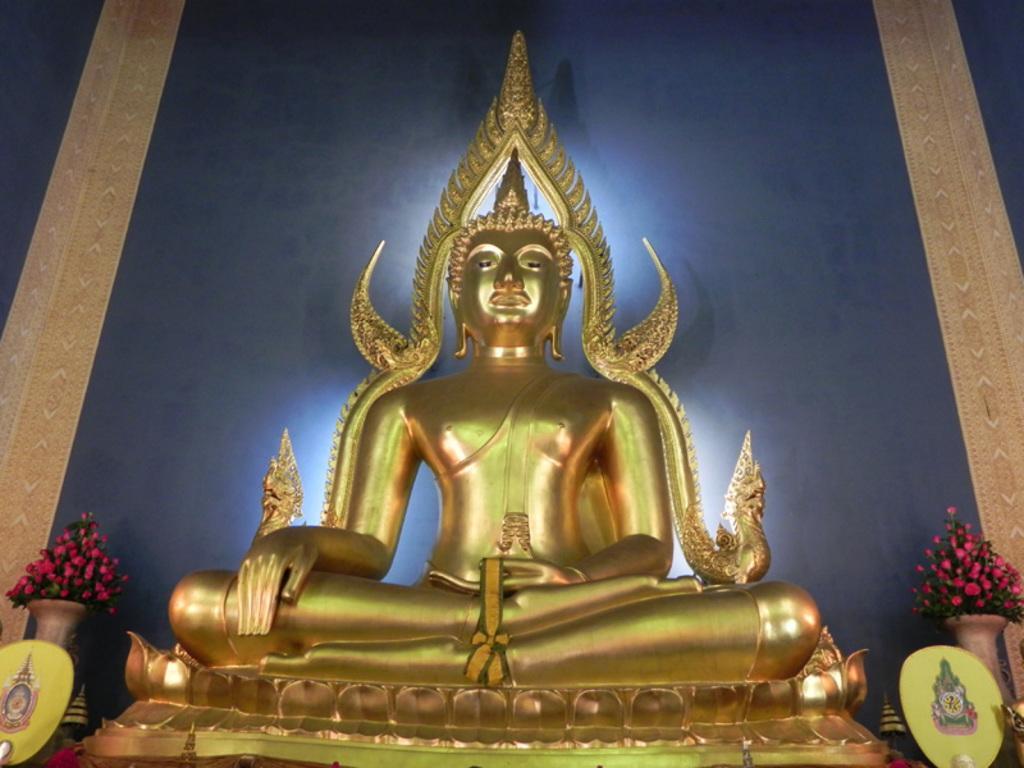In one or two sentences, can you explain what this image depicts? In this image we can see a statue. In the foreground we can see the ribbon. In the background, we can see boards with pictures, flowers in vases and the wall. 